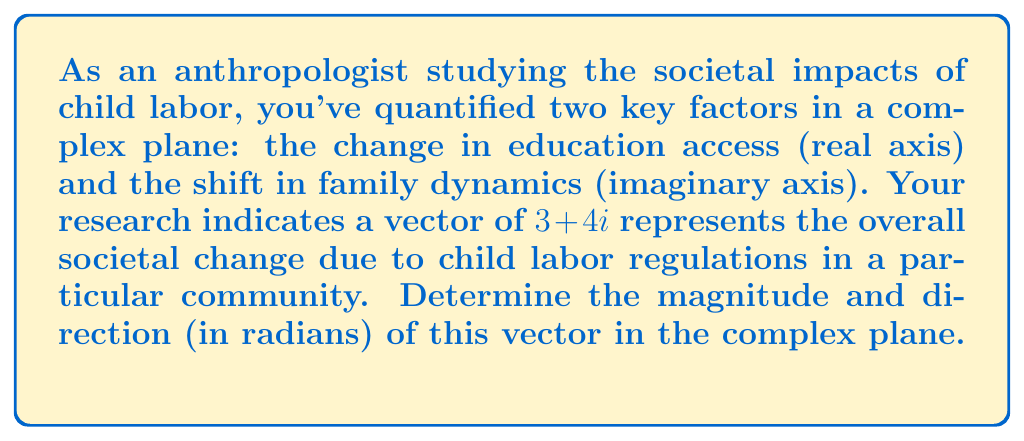Give your solution to this math problem. To solve this problem, we need to calculate the magnitude and direction of the complex number $3 + 4i$.

1. Magnitude:
   The magnitude of a complex number $z = a + bi$ is given by the formula:
   $$|z| = \sqrt{a^2 + b^2}$$
   
   In this case, $a = 3$ and $b = 4$:
   $$|z| = \sqrt{3^2 + 4^2} = \sqrt{9 + 16} = \sqrt{25} = 5$$

2. Direction:
   The direction of a complex number is given by its argument, which can be calculated using the arctangent function:
   $$\theta = \arctan(\frac{b}{a})$$
   
   However, we need to be careful to use the correct quadrant. Since both real and imaginary parts are positive, we're in the first quadrant, so we can use this formula directly:
   
   $$\theta = \arctan(\frac{4}{3}) \approx 0.9272952180$$

   This result is in radians.

Interpretation:
- The magnitude of 5 indicates the overall strength of the societal change.
- The direction of approximately 0.93 radians (about 53.13 degrees) shows that the change in family dynamics (imaginary axis) is slightly more pronounced than the change in education access (real axis).
Answer: Magnitude: 5
Direction: 0.9272952180 radians 